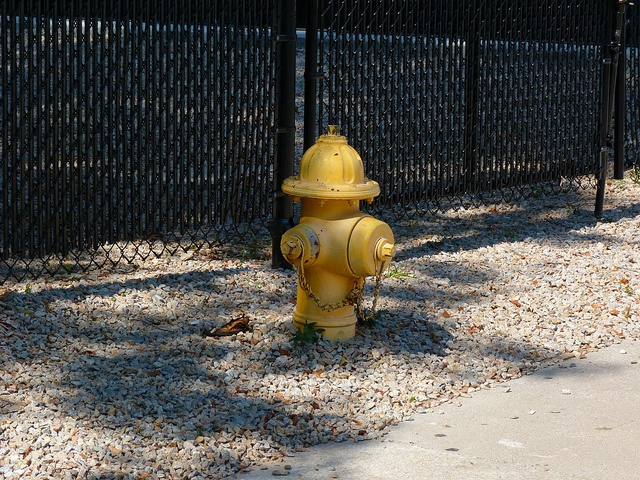Describe the objects in this image and their specific colors. I can see a fire hydrant in black, olive, and tan tones in this image. 